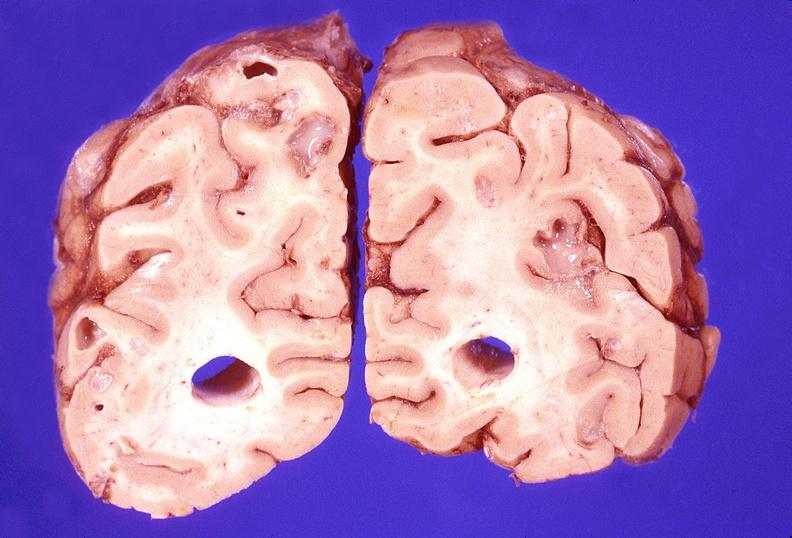s hemorrhagic corpus luteum present?
Answer the question using a single word or phrase. No 